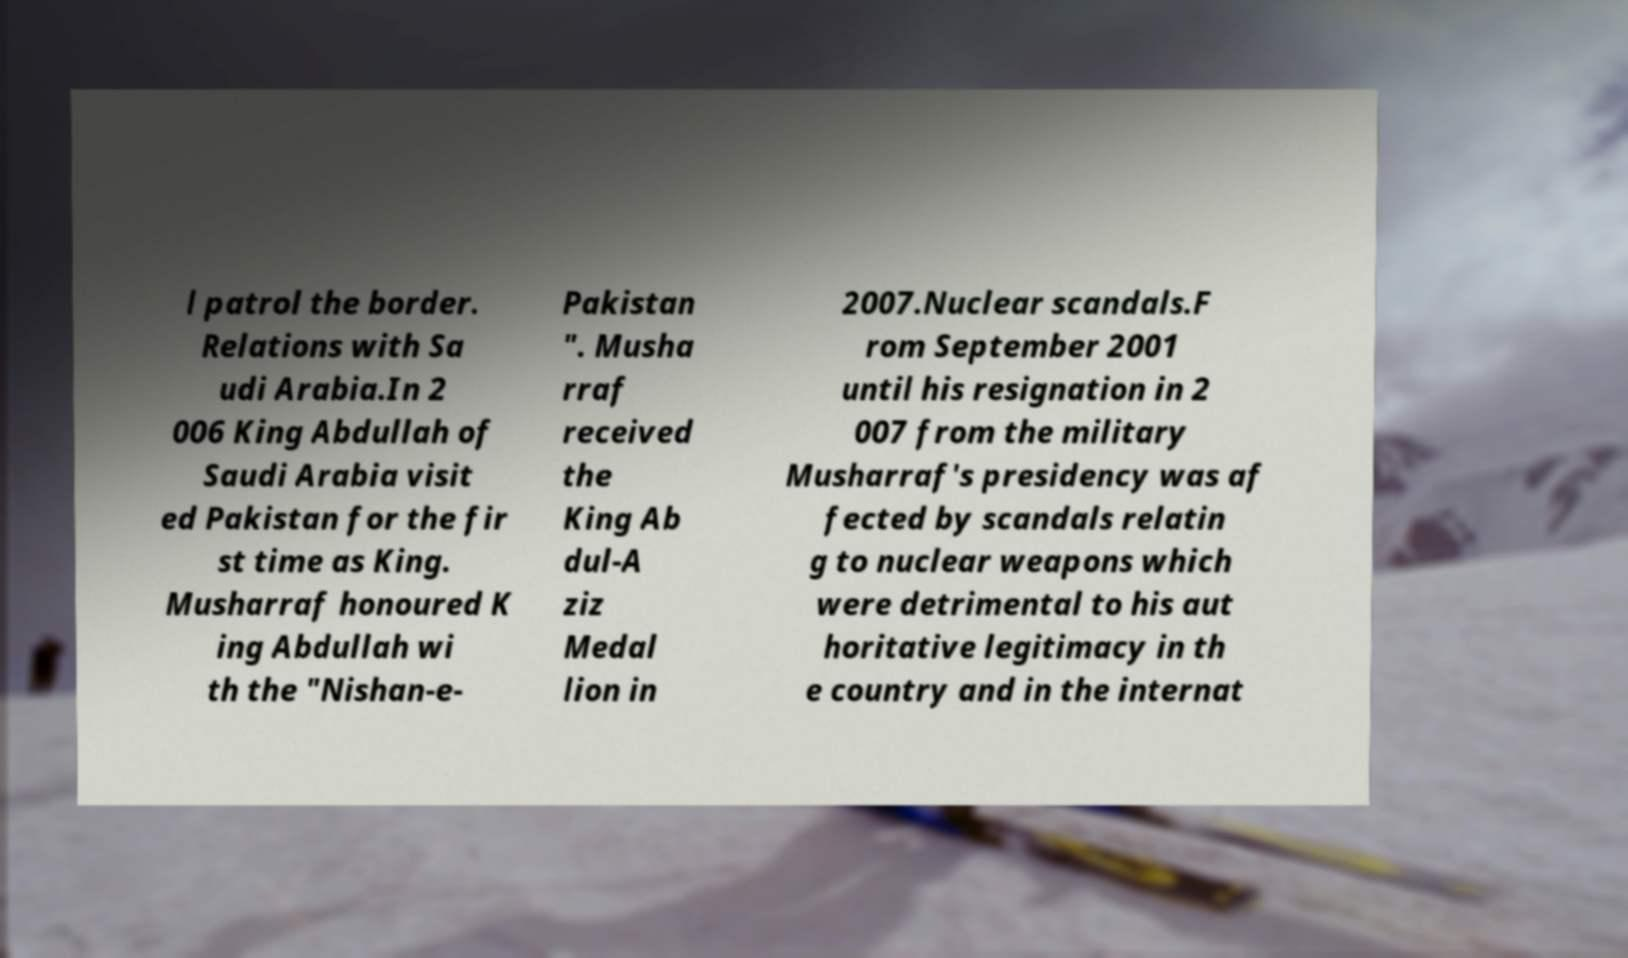Could you extract and type out the text from this image? l patrol the border. Relations with Sa udi Arabia.In 2 006 King Abdullah of Saudi Arabia visit ed Pakistan for the fir st time as King. Musharraf honoured K ing Abdullah wi th the "Nishan-e- Pakistan ". Musha rraf received the King Ab dul-A ziz Medal lion in 2007.Nuclear scandals.F rom September 2001 until his resignation in 2 007 from the military Musharraf's presidency was af fected by scandals relatin g to nuclear weapons which were detrimental to his aut horitative legitimacy in th e country and in the internat 